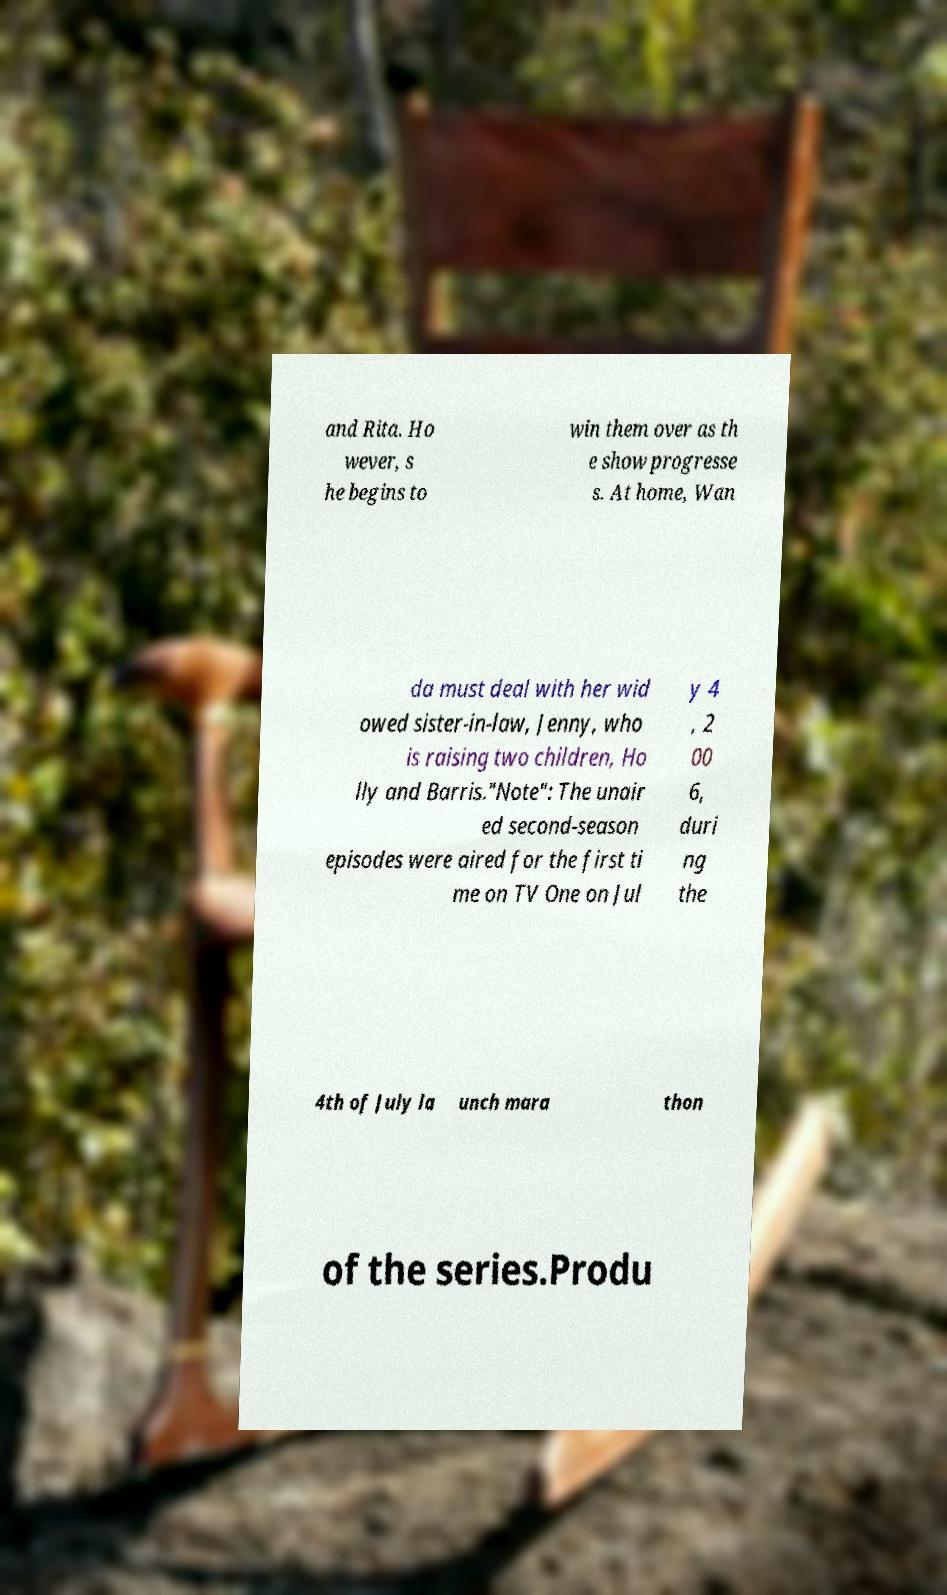Can you accurately transcribe the text from the provided image for me? and Rita. Ho wever, s he begins to win them over as th e show progresse s. At home, Wan da must deal with her wid owed sister-in-law, Jenny, who is raising two children, Ho lly and Barris."Note": The unair ed second-season episodes were aired for the first ti me on TV One on Jul y 4 , 2 00 6, duri ng the 4th of July la unch mara thon of the series.Produ 